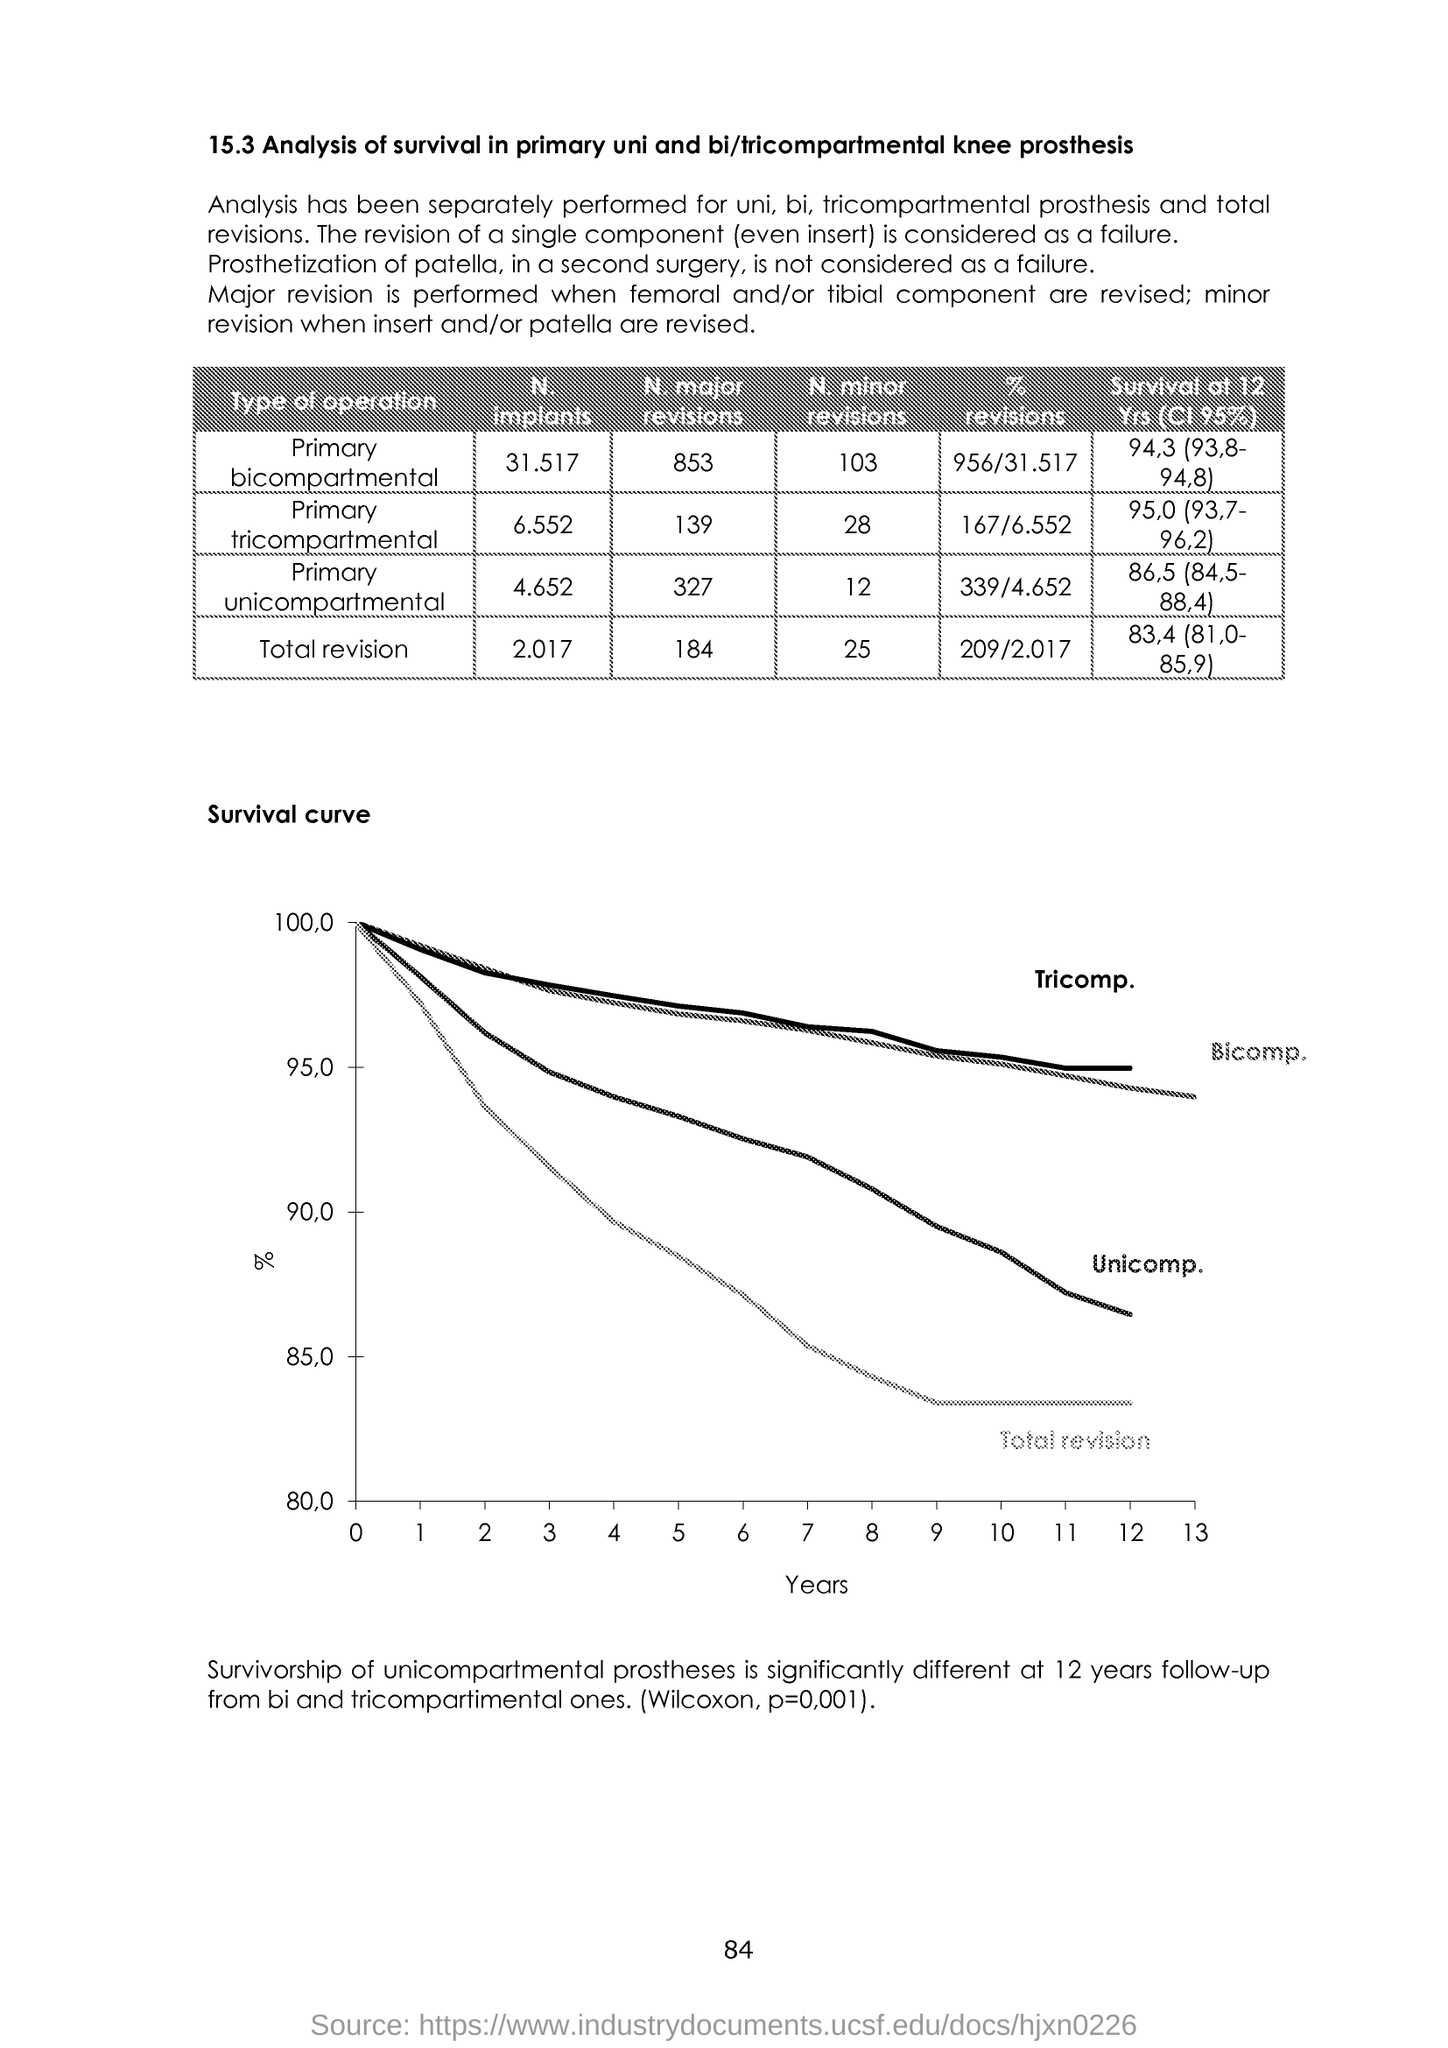What can you infer about the trend in revision rates among different types of knee prostheses? From the survival curve, we can infer that unicomparmental knee prostheses have a higher revision rate over time compared to bicompartmental and tricompartmental prostheses, as indicated by their curve being lower and declining faster. In contrast, tricompartmental prostheses show the highest survivability rate with the flattest decline, suggesting they are the most durable and least likely to require revision surgeries within the time frame shown. 